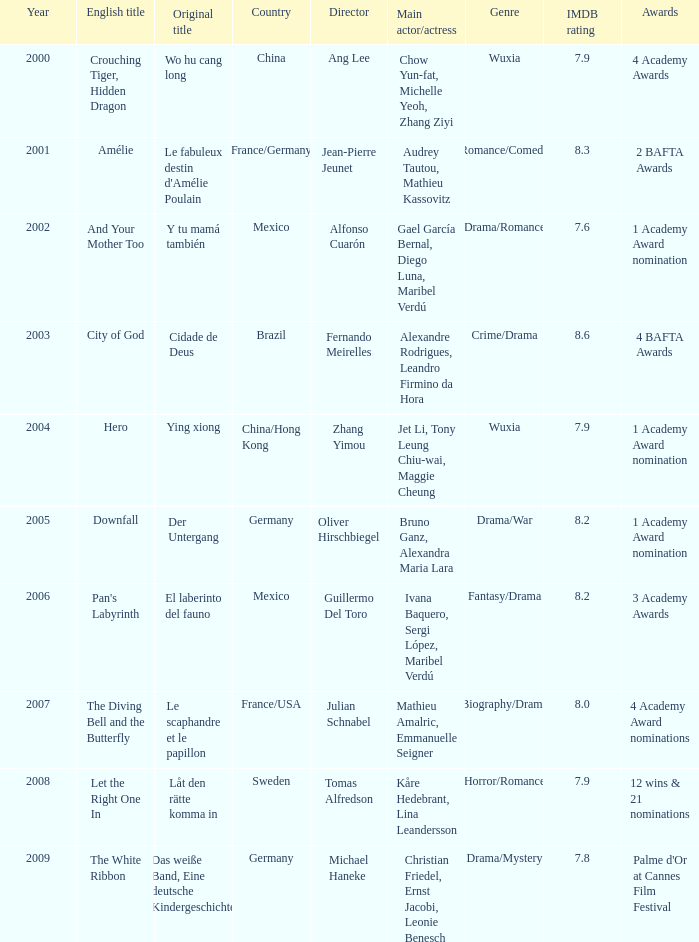Could you help me parse every detail presented in this table? {'header': ['Year', 'English title', 'Original title', 'Country', 'Director', 'Main actor/actress', 'Genre', 'IMDB rating', 'Awards'], 'rows': [['2000', 'Crouching Tiger, Hidden Dragon', 'Wo hu cang long', 'China', 'Ang Lee', 'Chow Yun-fat, Michelle Yeoh, Zhang Ziyi', 'Wuxia', '7.9', '4 Academy Awards'], ['2001', 'Amélie', "Le fabuleux destin d'Amélie Poulain", 'France/Germany', 'Jean-Pierre Jeunet', 'Audrey Tautou, Mathieu Kassovitz', 'Romance/Comedy', '8.3', '2 BAFTA Awards'], ['2002', 'And Your Mother Too', 'Y tu mamá también', 'Mexico', 'Alfonso Cuarón', 'Gael García Bernal, Diego Luna, Maribel Verdú', 'Drama/Romance', '7.6', '1 Academy Award nomination'], ['2003', 'City of God', 'Cidade de Deus', 'Brazil', 'Fernando Meirelles', 'Alexandre Rodrigues, Leandro Firmino da Hora', 'Crime/Drama', '8.6', '4 BAFTA Awards'], ['2004', 'Hero', 'Ying xiong', 'China/Hong Kong', 'Zhang Yimou', 'Jet Li, Tony Leung Chiu-wai, Maggie Cheung', 'Wuxia', '7.9', '1 Academy Award nomination'], ['2005', 'Downfall', 'Der Untergang', 'Germany', 'Oliver Hirschbiegel', 'Bruno Ganz, Alexandra Maria Lara', 'Drama/War', '8.2', '1 Academy Award nomination'], ['2006', "Pan's Labyrinth", 'El laberinto del fauno', 'Mexico', 'Guillermo Del Toro', 'Ivana Baquero, Sergi López, Maribel Verdú', 'Fantasy/Drama', '8.2', '3 Academy Awards'], ['2007', 'The Diving Bell and the Butterfly', 'Le scaphandre et le papillon', 'France/USA', 'Julian Schnabel', 'Mathieu Amalric, Emmanuelle Seigner', 'Biography/Drama', '8.0', '4 Academy Award nominations'], ['2008', 'Let the Right One In', 'Låt den rätte komma in', 'Sweden', 'Tomas Alfredson', 'Kåre Hedebrant, Lina Leandersson', 'Horror/Romance', '7.9', '12 wins & 21 nominations'], ['2009', 'The White Ribbon', 'Das weiße Band, Eine deutsche Kindergeschichte', 'Germany', 'Michael Haneke', 'Christian Friedel, Ernst Jacobi, Leonie Benesch', 'Drama/Mystery', '7.8', "Palme d'Or at Cannes Film Festival"]]} Name the title of jean-pierre jeunet Amélie. 